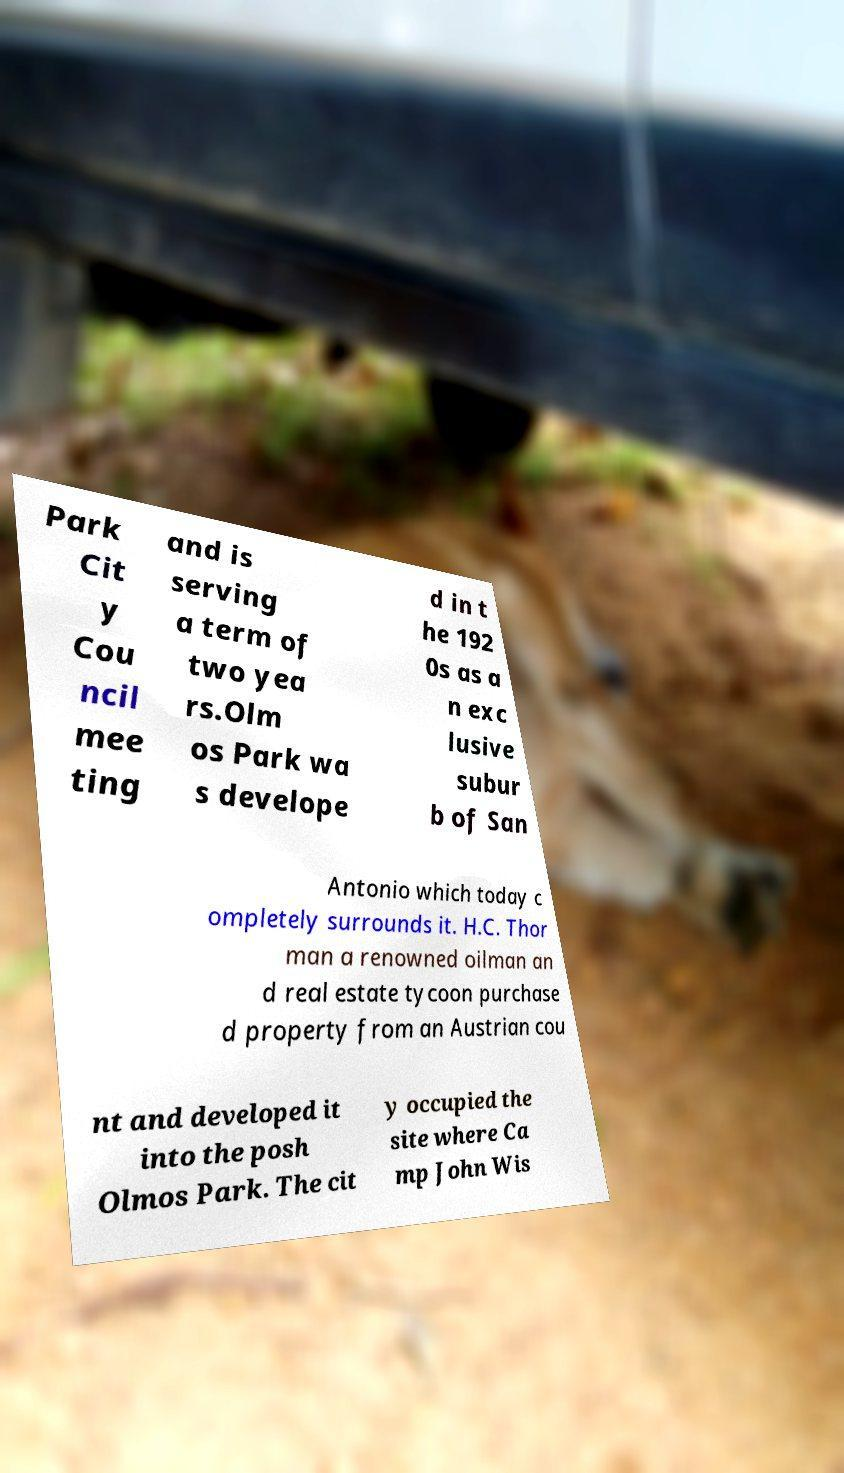Please identify and transcribe the text found in this image. Park Cit y Cou ncil mee ting and is serving a term of two yea rs.Olm os Park wa s develope d in t he 192 0s as a n exc lusive subur b of San Antonio which today c ompletely surrounds it. H.C. Thor man a renowned oilman an d real estate tycoon purchase d property from an Austrian cou nt and developed it into the posh Olmos Park. The cit y occupied the site where Ca mp John Wis 